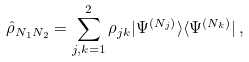Convert formula to latex. <formula><loc_0><loc_0><loc_500><loc_500>\hat { \rho } _ { N _ { 1 } N _ { 2 } } = \sum _ { j , k = 1 } ^ { 2 } \rho _ { j k } | \Psi ^ { ( N _ { j } ) } \rangle \langle \Psi ^ { ( N _ { k } ) } | \, ,</formula> 